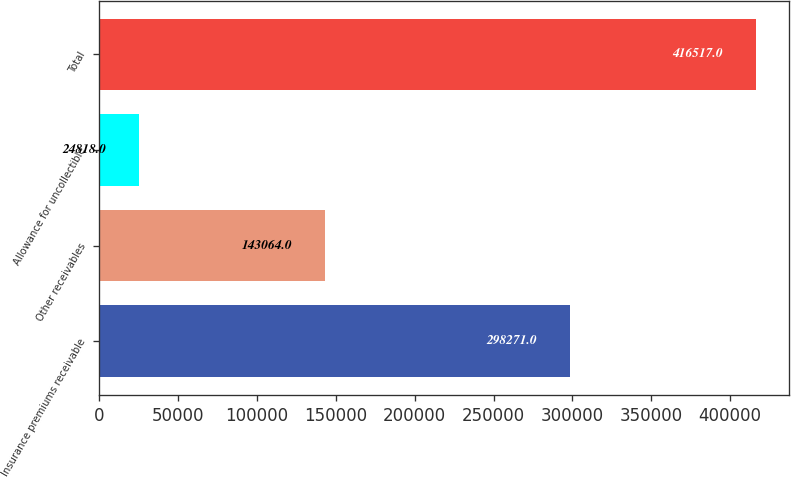<chart> <loc_0><loc_0><loc_500><loc_500><bar_chart><fcel>Insurance premiums receivable<fcel>Other receivables<fcel>Allowance for uncollectible<fcel>Total<nl><fcel>298271<fcel>143064<fcel>24818<fcel>416517<nl></chart> 